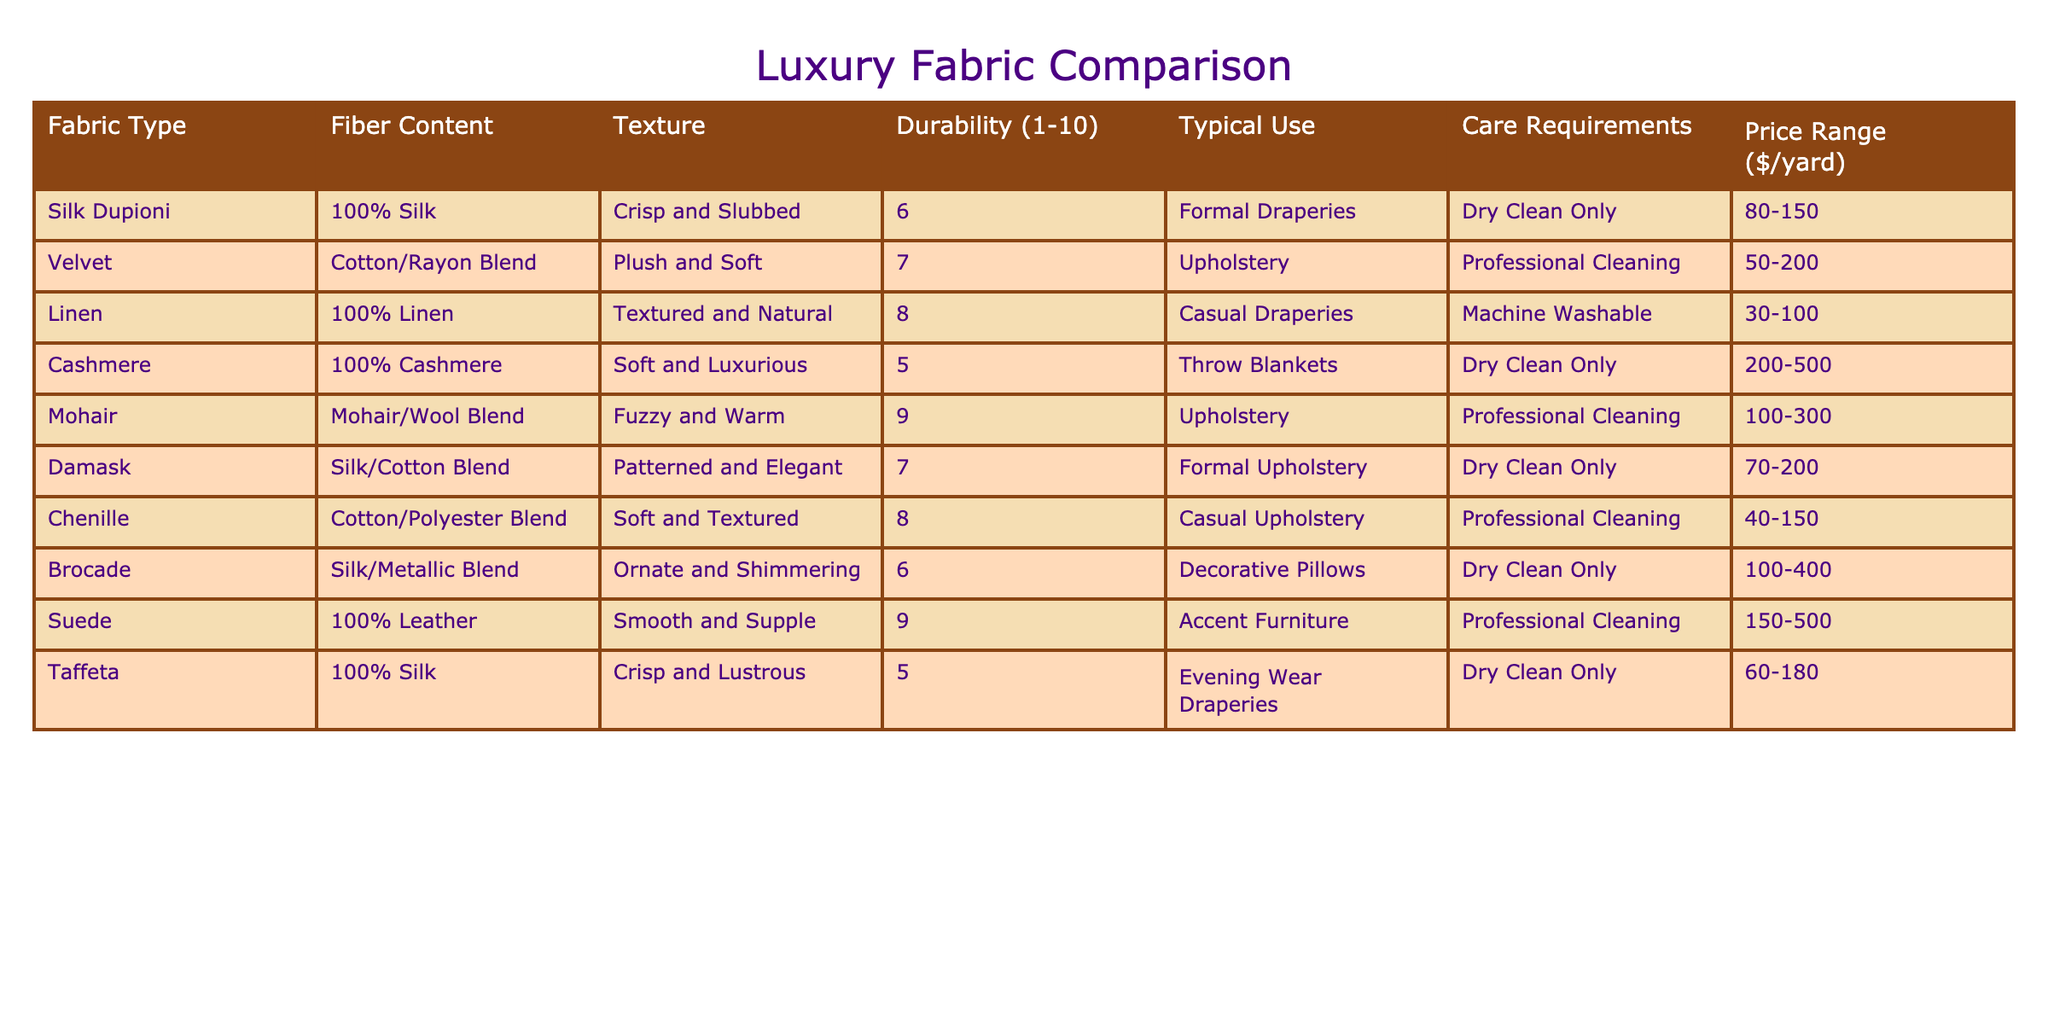What is the fiber content of Velvet? Velvet is made from a Cotton/Rayon Blend according to the table provided.
Answer: Cotton/Rayon Blend Which fabric has the highest durability rating? Comparing the durability ratings in the table, Mohair has the highest rating of 9.
Answer: Mohair Is Silk Dupioni suitable for casual draperies? The typical use for Silk Dupioni is formal draperies, not casual.
Answer: No What is the price range for Cashmere? According to the table, the price range for Cashmere is $200-500 per yard.
Answer: $200-500 How many fabric types have a durability rating of 8 or higher? There are three fabric types—Linen, Mohair, and Chenille—that have durability ratings of 8 or higher.
Answer: 3 Which fabric type requires dry cleaning only and is used for throw blankets? Cashmere is the only fabric that needs dry cleaning only and is categorized for use in throw blankets.
Answer: No What is the average price range of the fabrics listed? To find the average, we sum the individual midpoints of price ranges: Silk Dupioni ($115), Velvet ($125), Linen ($65), Cashmere ($350), Mohair ($200), Damask ($135), Chenille ($95), Brocade ($250), Suede ($325), and Taffeta ($120). The midpoints are summed up (115 + 125 + 65 + 350 + 200 + 135 + 95 + 250 + 325 + 120) = 1,775. We divide by 10 fabrics to get an average of $177.50.
Answer: $177.50 Which fabric has the softest texture? Cashmere is described as soft and luxurious, making it the softest among the fabrics listed.
Answer: Cashmere Is there a fabric type that is both 100% silk and requires dry cleaning? Yes, both Silk Dupioni and Taffeta are 100% silk fabrics that require dry cleaning only.
Answer: Yes Among the fabrics that require professional cleaning, which one has the lowest price range? The lowest price range among these is for Chenille, which ranges from $40 to $150.
Answer: Chenille What is the typical use for Brocade? The typical use for Brocade, according to the table, is for decorative pillows.
Answer: Decorative Pillows 